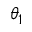<formula> <loc_0><loc_0><loc_500><loc_500>\theta _ { 1 }</formula> 